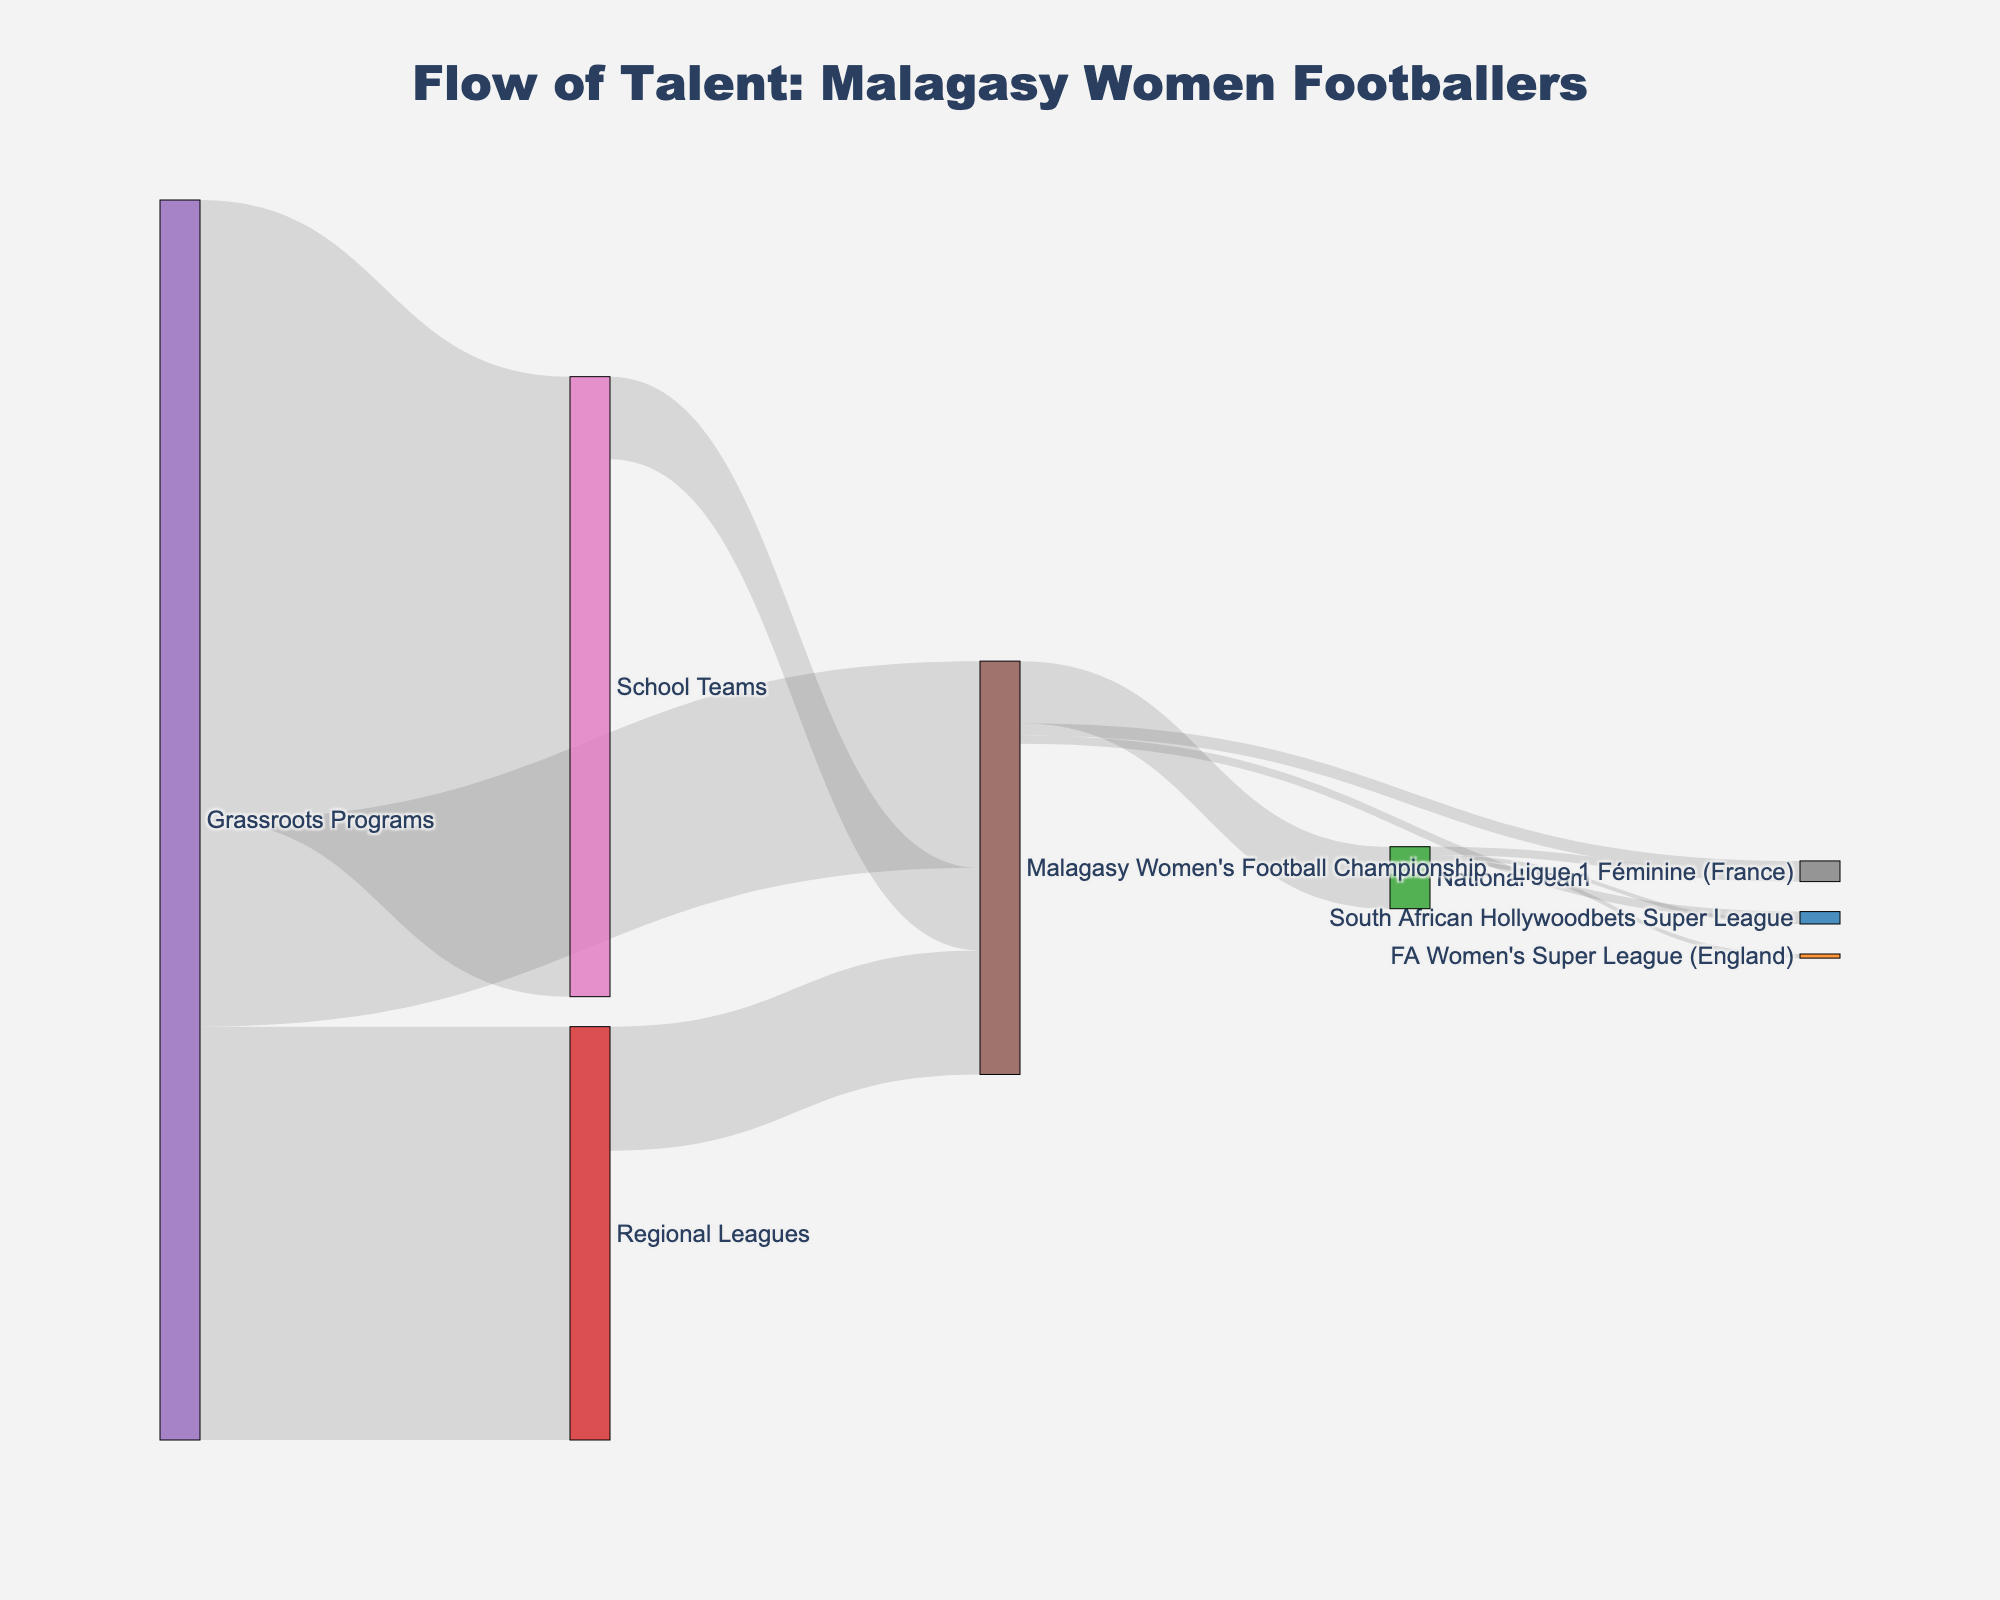What's the title of the figure? The title is usually placed at the top of the chart and is often the largest piece of text, centered for emphasis.
Answer: Flow of Talent: Malagasy Women Footballers How many grassroots programs feed into the Malagasy Women's Football Championship? Look for connections flowing directly from Grassroots Programs to Malagasy Women's Football Championship.
Answer: 50 What is the total number of players coming from Grassroots Programs? Sum the values of all connections originating from Grassroots Programs: 50 + 100 + 150.
Answer: 300 Which pathway has the least number of players moving to the Ligue 1 Féminine in France? Compare the links going to the Ligue 1 Féminine from different sources: 3 from Malagasy Women's Football Championship and 2 from National Team.
Answer: National Team How many players make it to professional leagues outside Madagascar? Sum the values of connections to Ligue 1 Féminine, South African Hollywoodbets Super League, and FA Women's Super League: 3 + 2 + 2 + 1.
Answer: 8 How does the number of players moving from School Teams to the Malagasy Women's Football Championship compare with those moving from Regional Leagues to the Championship? Compare the values of the two pathways: School Teams to Championship (20) and Regional Leagues to Championship (30).
Answer: Regional Leagues have more players How many players from the Malagasy Women's Football Championship end up in the National Team? Look for the connection from Malagasy Women's Football Championship going to National Team.
Answer: 15 What's the difference between the number of players that proceed from School Teams to the Malagasy Women's Football Championship and those from Regional Leagues to the Championship? Calculate the difference between the two values: 30 (Regional) - 20 (School).
Answer: 10 How many players in total enter the Malagasy Women's Football Championship from any pathway? Sum the values of connections to the Championship: 50 (Grassroots) + 30 (Regional) + 20 (School).
Answer: 100 What percentage of players from the National Team go to foreign leagues? Combine the values of National Team to foreign leagues (2 + 1 + 1 = 4) and divide by the total National Team output (4 out of 15 + 4): (4 / 19) * 100.
Answer: 21.05% Which pathway has the highest flow of players reaching the National Team? Compare the link values leading to National Team: From Championship (15) is the only pathway, no further calculation needed.
Answer: Malagasy Women's Football Championship 